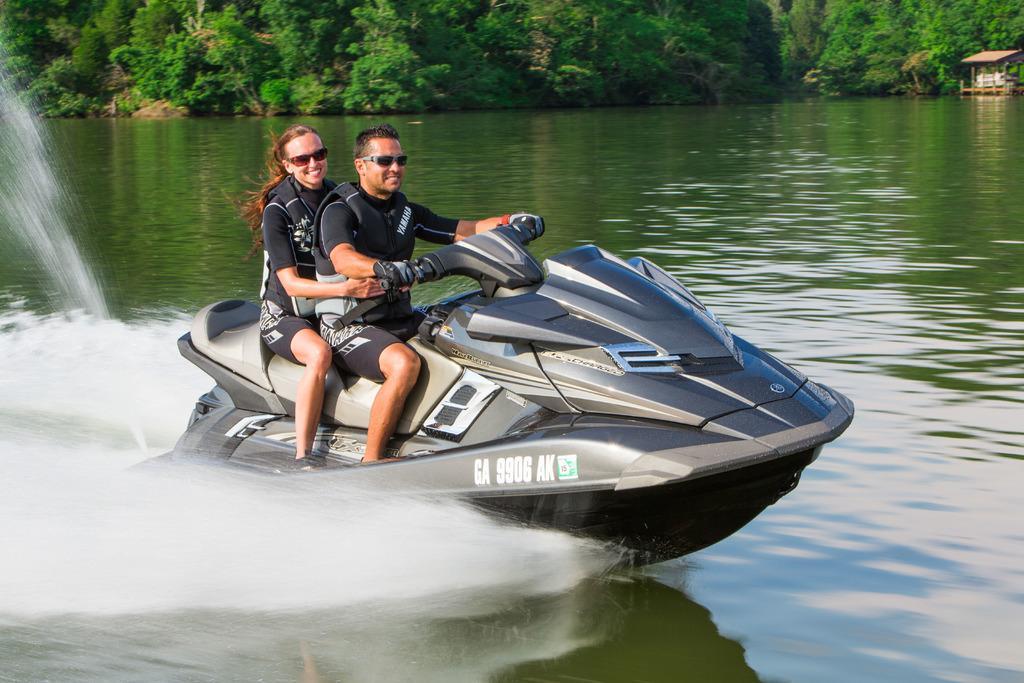Can you describe this image briefly? In the foreground, I can see two persons are boating in the water. In the background, I can see trees and a shed. This image taken, maybe in a lake. 